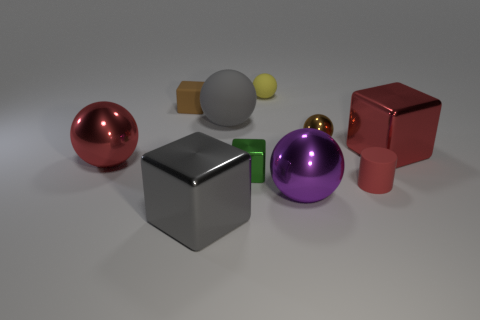The red sphere that is made of the same material as the purple object is what size?
Provide a succinct answer. Large. There is a tiny cylinder; is it the same color as the big shiny thing on the right side of the brown ball?
Keep it short and to the point. Yes. What material is the large thing that is in front of the big red metallic ball and on the left side of the small yellow rubber object?
Your answer should be compact. Metal. What is the size of the ball that is the same color as the tiny rubber cylinder?
Your answer should be compact. Large. There is a large gray thing in front of the large red block; does it have the same shape as the thing that is to the right of the small red cylinder?
Give a very brief answer. Yes. Is there a big purple rubber cube?
Your answer should be compact. No. There is another small thing that is the same shape as the brown metallic object; what is its color?
Your response must be concise. Yellow. The other cube that is the same size as the green cube is what color?
Provide a short and direct response. Brown. Does the red cylinder have the same material as the gray sphere?
Provide a short and direct response. Yes. How many big cubes have the same color as the tiny cylinder?
Ensure brevity in your answer.  1. 